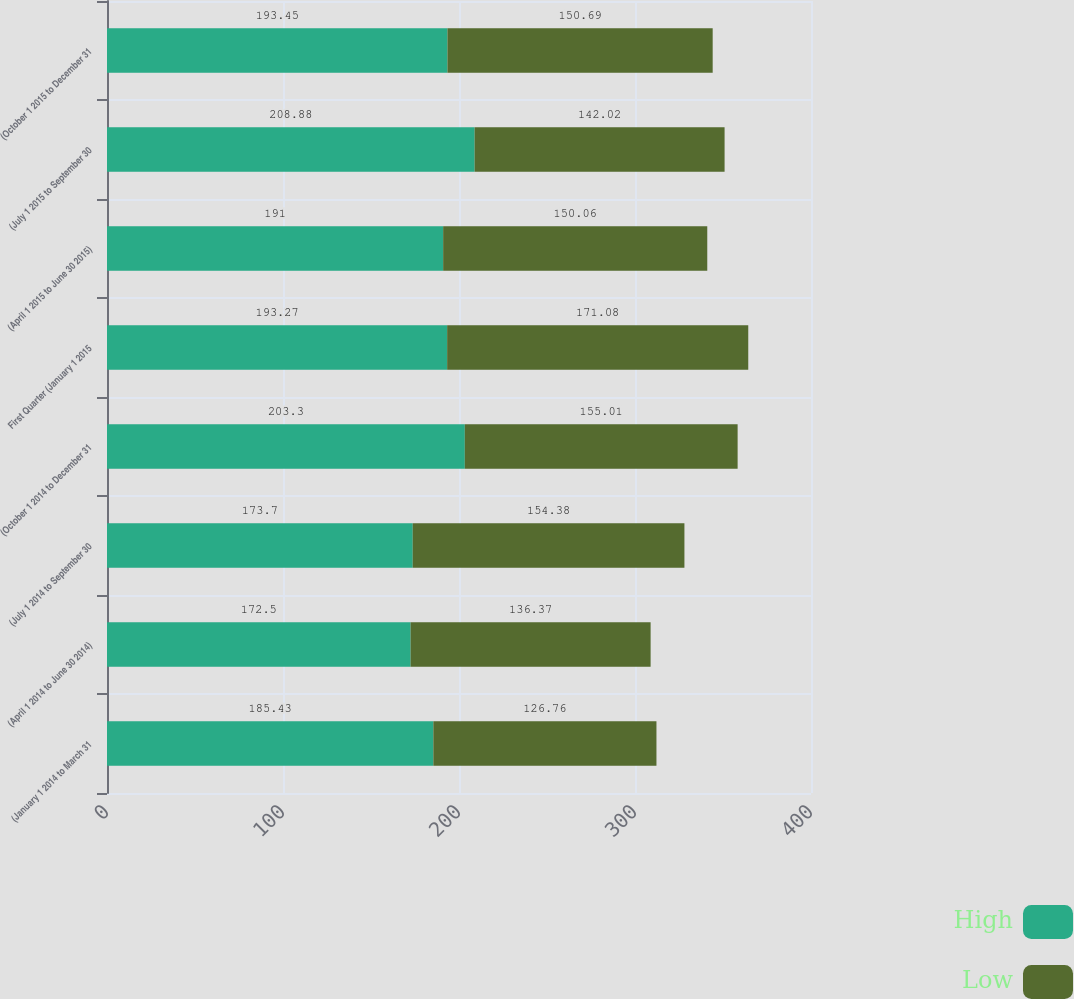<chart> <loc_0><loc_0><loc_500><loc_500><stacked_bar_chart><ecel><fcel>(January 1 2014 to March 31<fcel>(April 1 2014 to June 30 2014)<fcel>(July 1 2014 to September 30<fcel>(October 1 2014 to December 31<fcel>First Quarter (January 1 2015<fcel>(April 1 2015 to June 30 2015)<fcel>(July 1 2015 to September 30<fcel>(October 1 2015 to December 31<nl><fcel>High<fcel>185.43<fcel>172.5<fcel>173.7<fcel>203.3<fcel>193.27<fcel>191<fcel>208.88<fcel>193.45<nl><fcel>Low<fcel>126.76<fcel>136.37<fcel>154.38<fcel>155.01<fcel>171.08<fcel>150.06<fcel>142.02<fcel>150.69<nl></chart> 